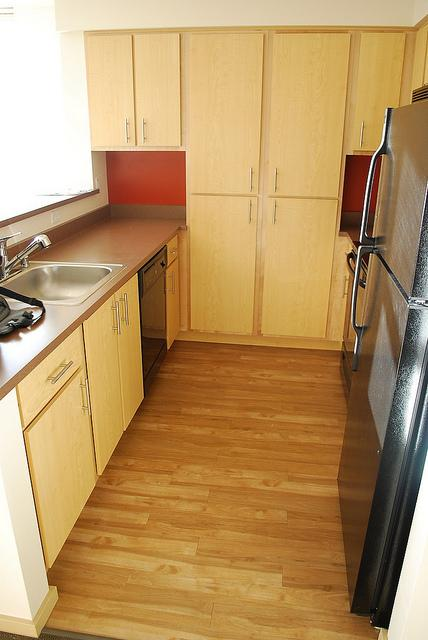What is going on with this room? kitchen 